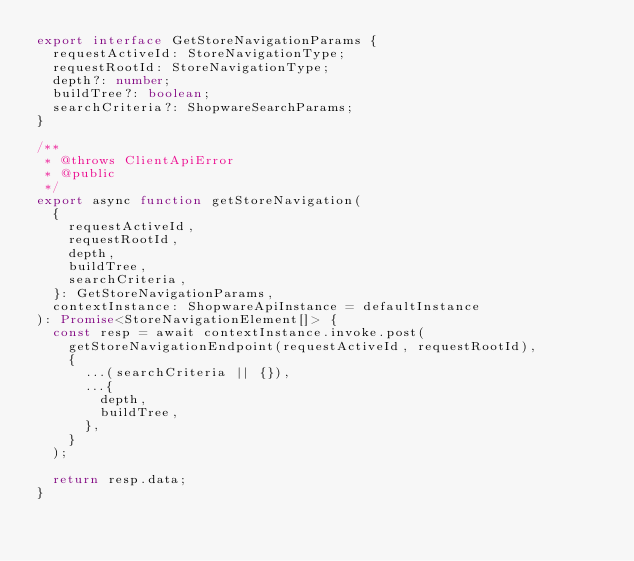Convert code to text. <code><loc_0><loc_0><loc_500><loc_500><_TypeScript_>export interface GetStoreNavigationParams {
  requestActiveId: StoreNavigationType;
  requestRootId: StoreNavigationType;
  depth?: number;
  buildTree?: boolean;
  searchCriteria?: ShopwareSearchParams;
}

/**
 * @throws ClientApiError
 * @public
 */
export async function getStoreNavigation(
  {
    requestActiveId,
    requestRootId,
    depth,
    buildTree,
    searchCriteria,
  }: GetStoreNavigationParams,
  contextInstance: ShopwareApiInstance = defaultInstance
): Promise<StoreNavigationElement[]> {
  const resp = await contextInstance.invoke.post(
    getStoreNavigationEndpoint(requestActiveId, requestRootId),
    {
      ...(searchCriteria || {}),
      ...{
        depth,
        buildTree,
      },
    }
  );

  return resp.data;
}
</code> 